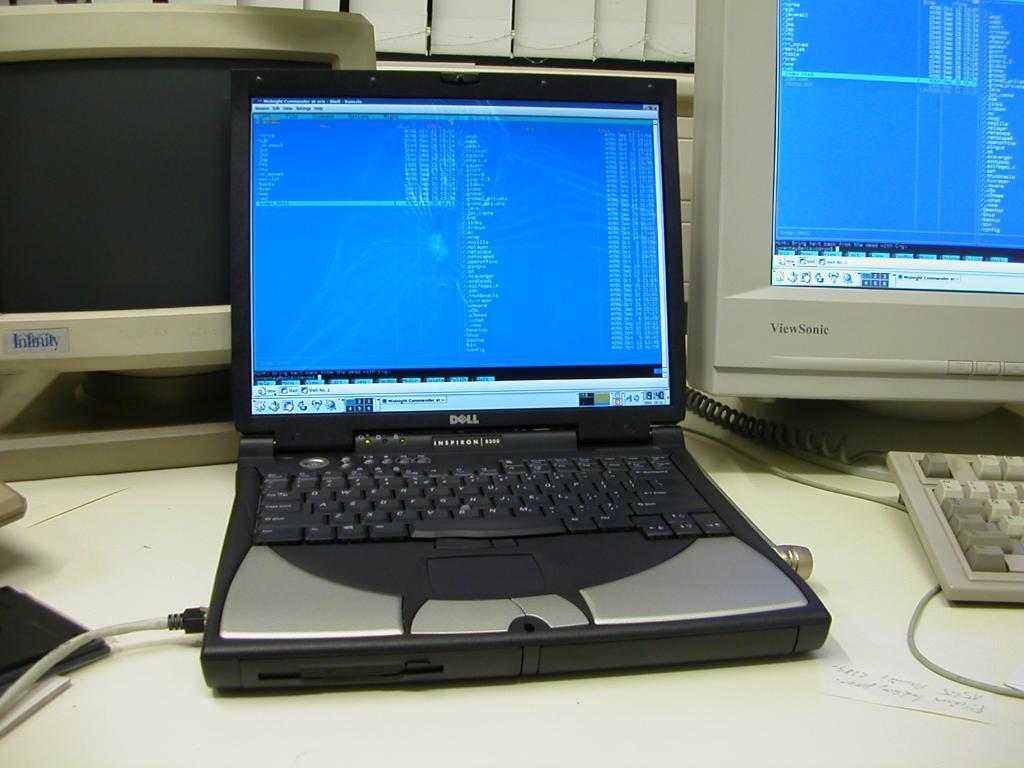What brand is this laptop?
Ensure brevity in your answer.  Dell. 